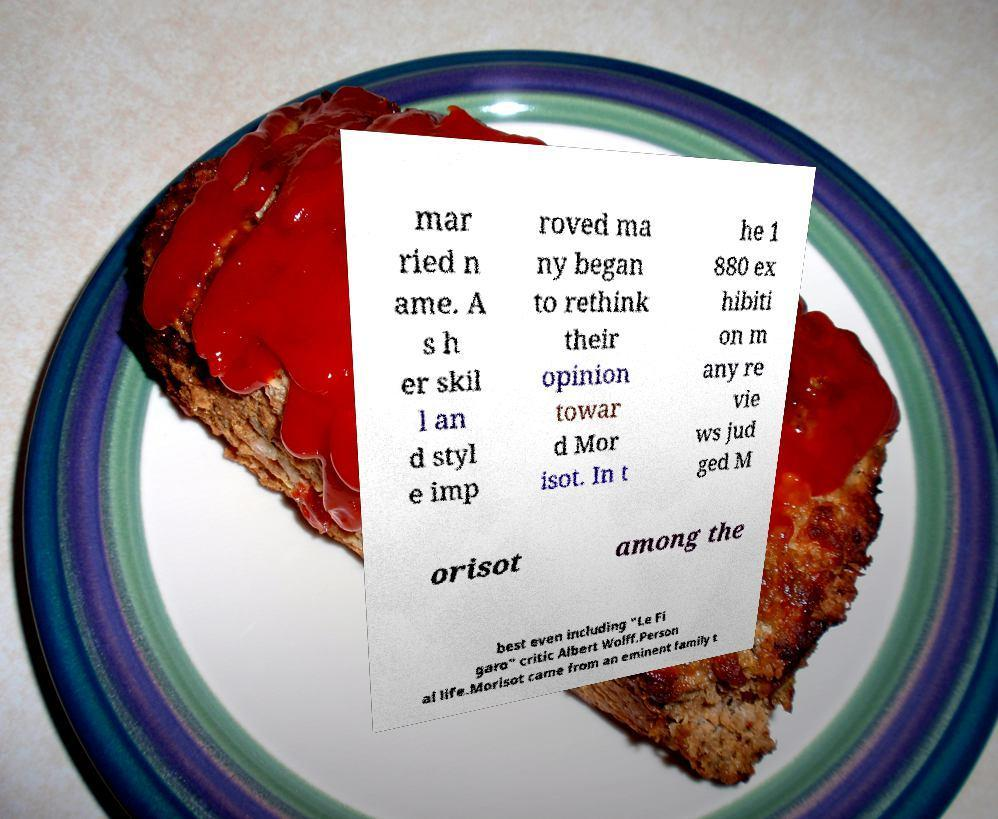Could you assist in decoding the text presented in this image and type it out clearly? mar ried n ame. A s h er skil l an d styl e imp roved ma ny began to rethink their opinion towar d Mor isot. In t he 1 880 ex hibiti on m any re vie ws jud ged M orisot among the best even including "Le Fi garo" critic Albert Wolff.Person al life.Morisot came from an eminent family t 